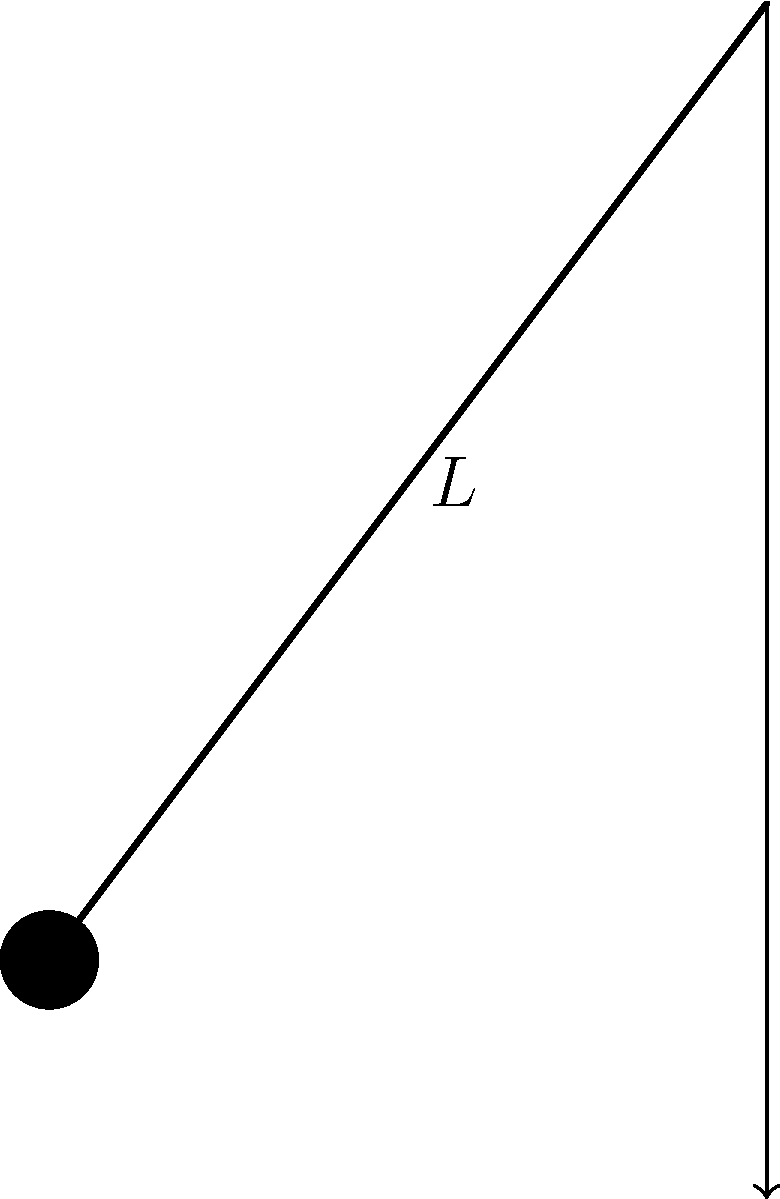In your Physics class at Jenks High School, you learned about simple pendulums. Consider a simple pendulum with a length of 2.5 meters. Calculate its period, assuming it is located on Earth where the acceleration due to gravity is 9.8 m/s². Round your answer to two decimal places. To calculate the period of a simple pendulum, we use the formula:

$$T = 2\pi \sqrt{\frac{L}{g}}$$

Where:
$T$ is the period (in seconds)
$L$ is the length of the pendulum (in meters)
$g$ is the acceleration due to gravity (in m/s²)

Given:
$L = 2.5$ m
$g = 9.8$ m/s²

Step 1: Substitute the values into the formula.
$$T = 2\pi \sqrt{\frac{2.5}{9.8}}$$

Step 2: Simplify the fraction under the square root.
$$T = 2\pi \sqrt{0.255102041}$$

Step 3: Calculate the square root.
$$T = 2\pi \cdot 0.505075296$$

Step 4: Multiply by $2\pi$.
$$T = 3.17305351$$

Step 5: Round to two decimal places.
$$T \approx 3.17 \text{ seconds}$$
Answer: 3.17 s 